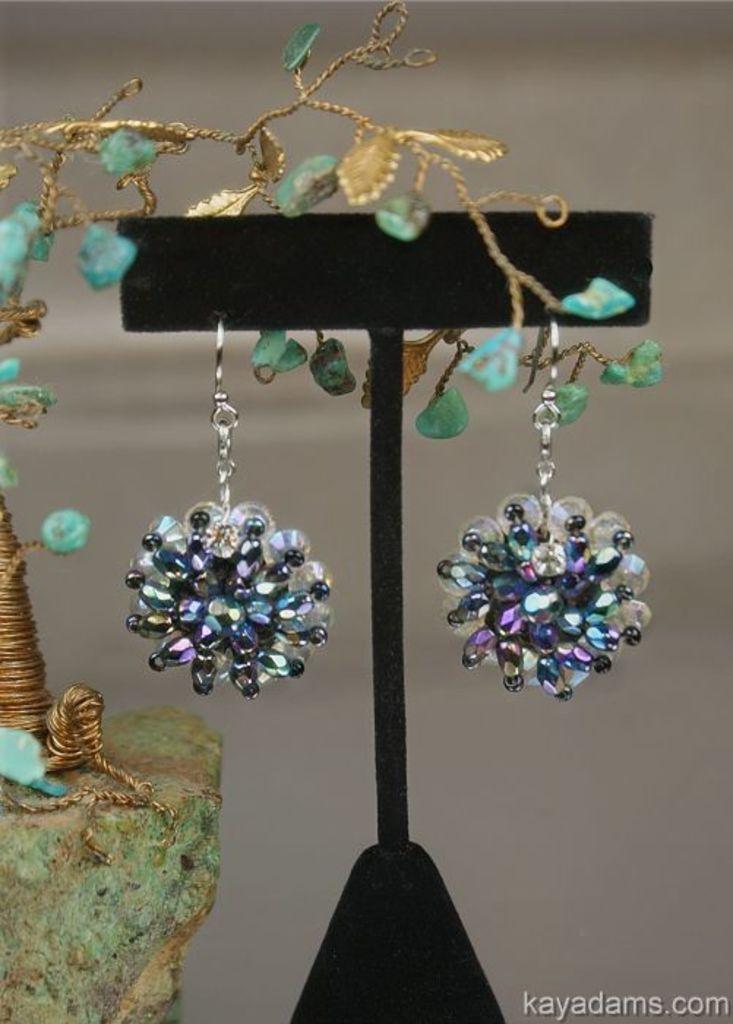How would you summarize this image in a sentence or two? In this image I can see a black colour thing and few earrings. I can also see few other stuffs over here and I can see this image is little bit blurry from background. 